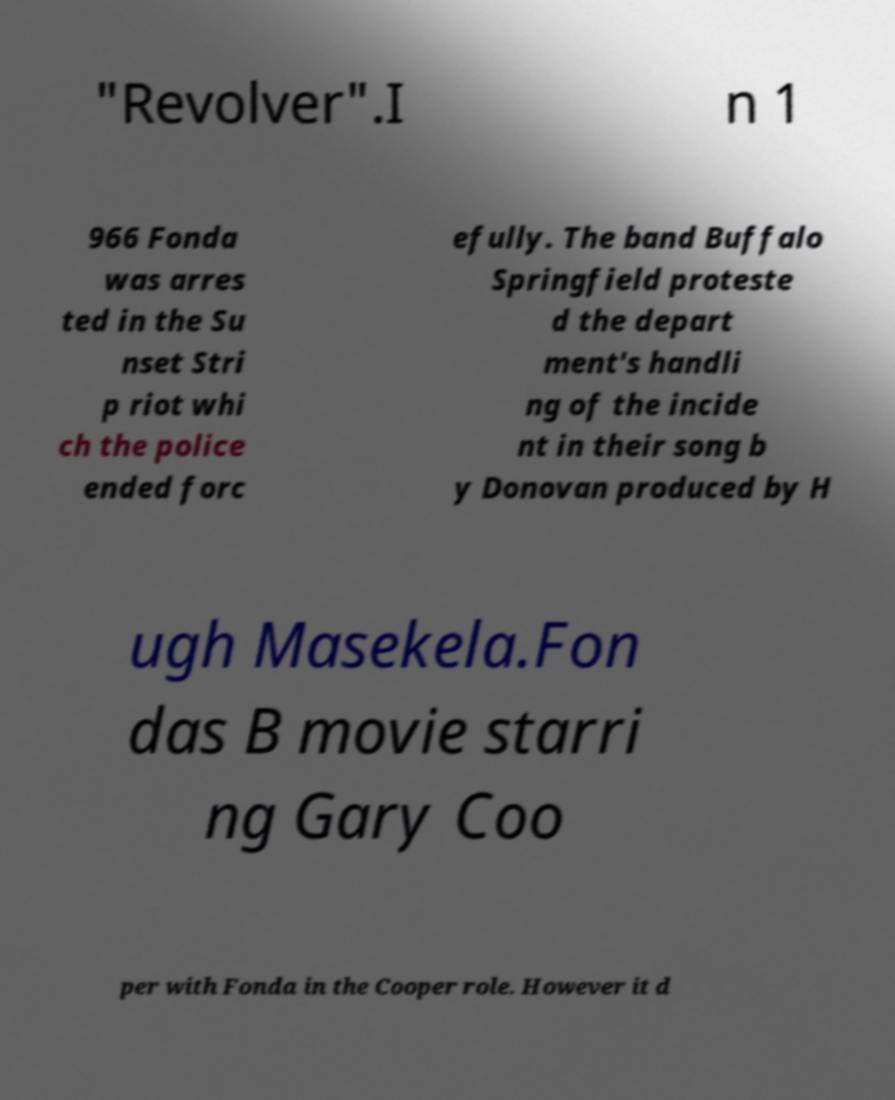I need the written content from this picture converted into text. Can you do that? "Revolver".I n 1 966 Fonda was arres ted in the Su nset Stri p riot whi ch the police ended forc efully. The band Buffalo Springfield proteste d the depart ment's handli ng of the incide nt in their song b y Donovan produced by H ugh Masekela.Fon das B movie starri ng Gary Coo per with Fonda in the Cooper role. However it d 